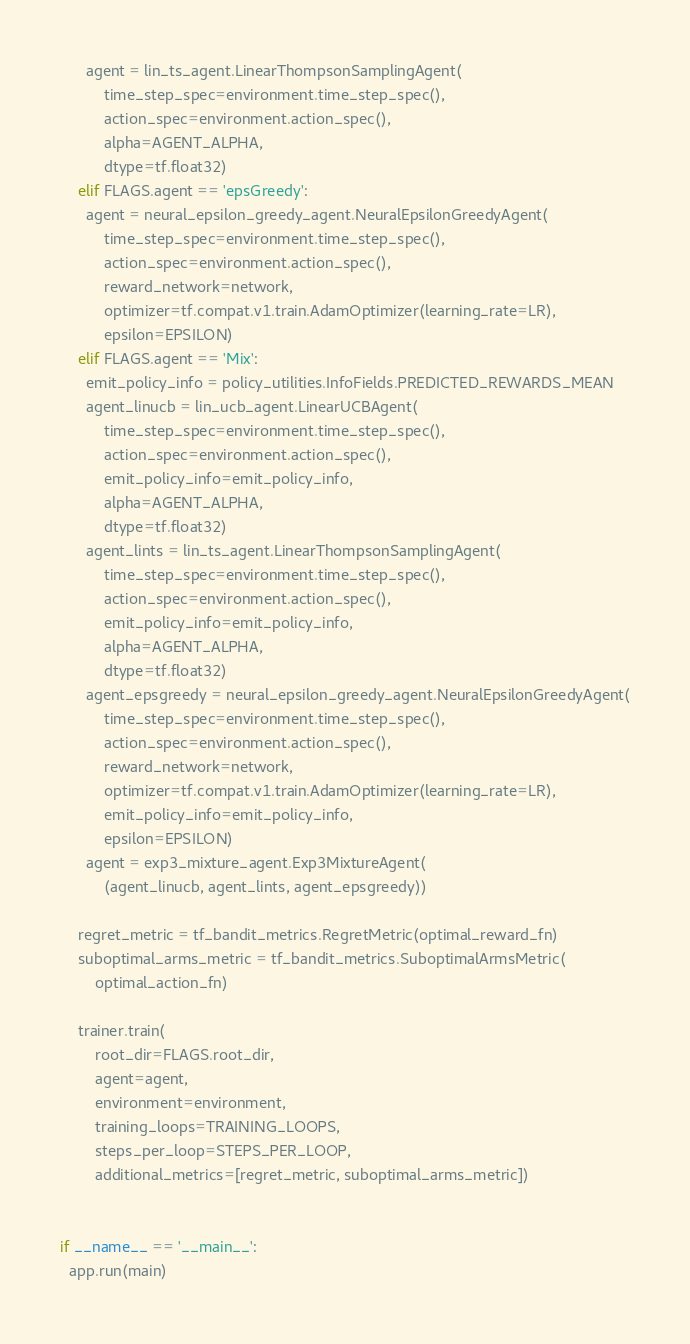<code> <loc_0><loc_0><loc_500><loc_500><_Python_>      agent = lin_ts_agent.LinearThompsonSamplingAgent(
          time_step_spec=environment.time_step_spec(),
          action_spec=environment.action_spec(),
          alpha=AGENT_ALPHA,
          dtype=tf.float32)
    elif FLAGS.agent == 'epsGreedy':
      agent = neural_epsilon_greedy_agent.NeuralEpsilonGreedyAgent(
          time_step_spec=environment.time_step_spec(),
          action_spec=environment.action_spec(),
          reward_network=network,
          optimizer=tf.compat.v1.train.AdamOptimizer(learning_rate=LR),
          epsilon=EPSILON)
    elif FLAGS.agent == 'Mix':
      emit_policy_info = policy_utilities.InfoFields.PREDICTED_REWARDS_MEAN
      agent_linucb = lin_ucb_agent.LinearUCBAgent(
          time_step_spec=environment.time_step_spec(),
          action_spec=environment.action_spec(),
          emit_policy_info=emit_policy_info,
          alpha=AGENT_ALPHA,
          dtype=tf.float32)
      agent_lints = lin_ts_agent.LinearThompsonSamplingAgent(
          time_step_spec=environment.time_step_spec(),
          action_spec=environment.action_spec(),
          emit_policy_info=emit_policy_info,
          alpha=AGENT_ALPHA,
          dtype=tf.float32)
      agent_epsgreedy = neural_epsilon_greedy_agent.NeuralEpsilonGreedyAgent(
          time_step_spec=environment.time_step_spec(),
          action_spec=environment.action_spec(),
          reward_network=network,
          optimizer=tf.compat.v1.train.AdamOptimizer(learning_rate=LR),
          emit_policy_info=emit_policy_info,
          epsilon=EPSILON)
      agent = exp3_mixture_agent.Exp3MixtureAgent(
          (agent_linucb, agent_lints, agent_epsgreedy))

    regret_metric = tf_bandit_metrics.RegretMetric(optimal_reward_fn)
    suboptimal_arms_metric = tf_bandit_metrics.SuboptimalArmsMetric(
        optimal_action_fn)

    trainer.train(
        root_dir=FLAGS.root_dir,
        agent=agent,
        environment=environment,
        training_loops=TRAINING_LOOPS,
        steps_per_loop=STEPS_PER_LOOP,
        additional_metrics=[regret_metric, suboptimal_arms_metric])


if __name__ == '__main__':
  app.run(main)
</code> 